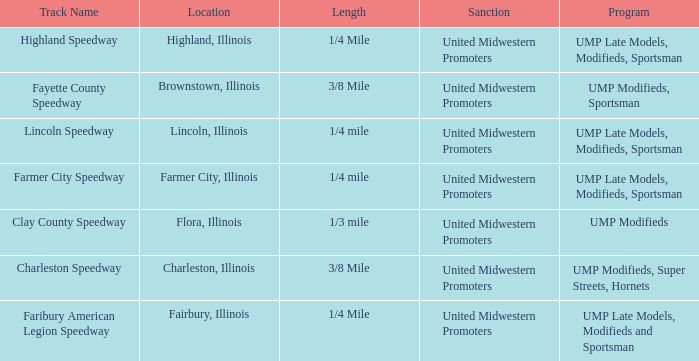Who sanctioned the event in lincoln, illinois? United Midwestern Promoters. Could you help me parse every detail presented in this table? {'header': ['Track Name', 'Location', 'Length', 'Sanction', 'Program'], 'rows': [['Highland Speedway', 'Highland, Illinois', '1/4 Mile', 'United Midwestern Promoters', 'UMP Late Models, Modifieds, Sportsman'], ['Fayette County Speedway', 'Brownstown, Illinois', '3/8 Mile', 'United Midwestern Promoters', 'UMP Modifieds, Sportsman'], ['Lincoln Speedway', 'Lincoln, Illinois', '1/4 mile', 'United Midwestern Promoters', 'UMP Late Models, Modifieds, Sportsman'], ['Farmer City Speedway', 'Farmer City, Illinois', '1/4 mile', 'United Midwestern Promoters', 'UMP Late Models, Modifieds, Sportsman'], ['Clay County Speedway', 'Flora, Illinois', '1/3 mile', 'United Midwestern Promoters', 'UMP Modifieds'], ['Charleston Speedway', 'Charleston, Illinois', '3/8 Mile', 'United Midwestern Promoters', 'UMP Modifieds, Super Streets, Hornets'], ['Faribury American Legion Speedway', 'Fairbury, Illinois', '1/4 Mile', 'United Midwestern Promoters', 'UMP Late Models, Modifieds and Sportsman']]} 